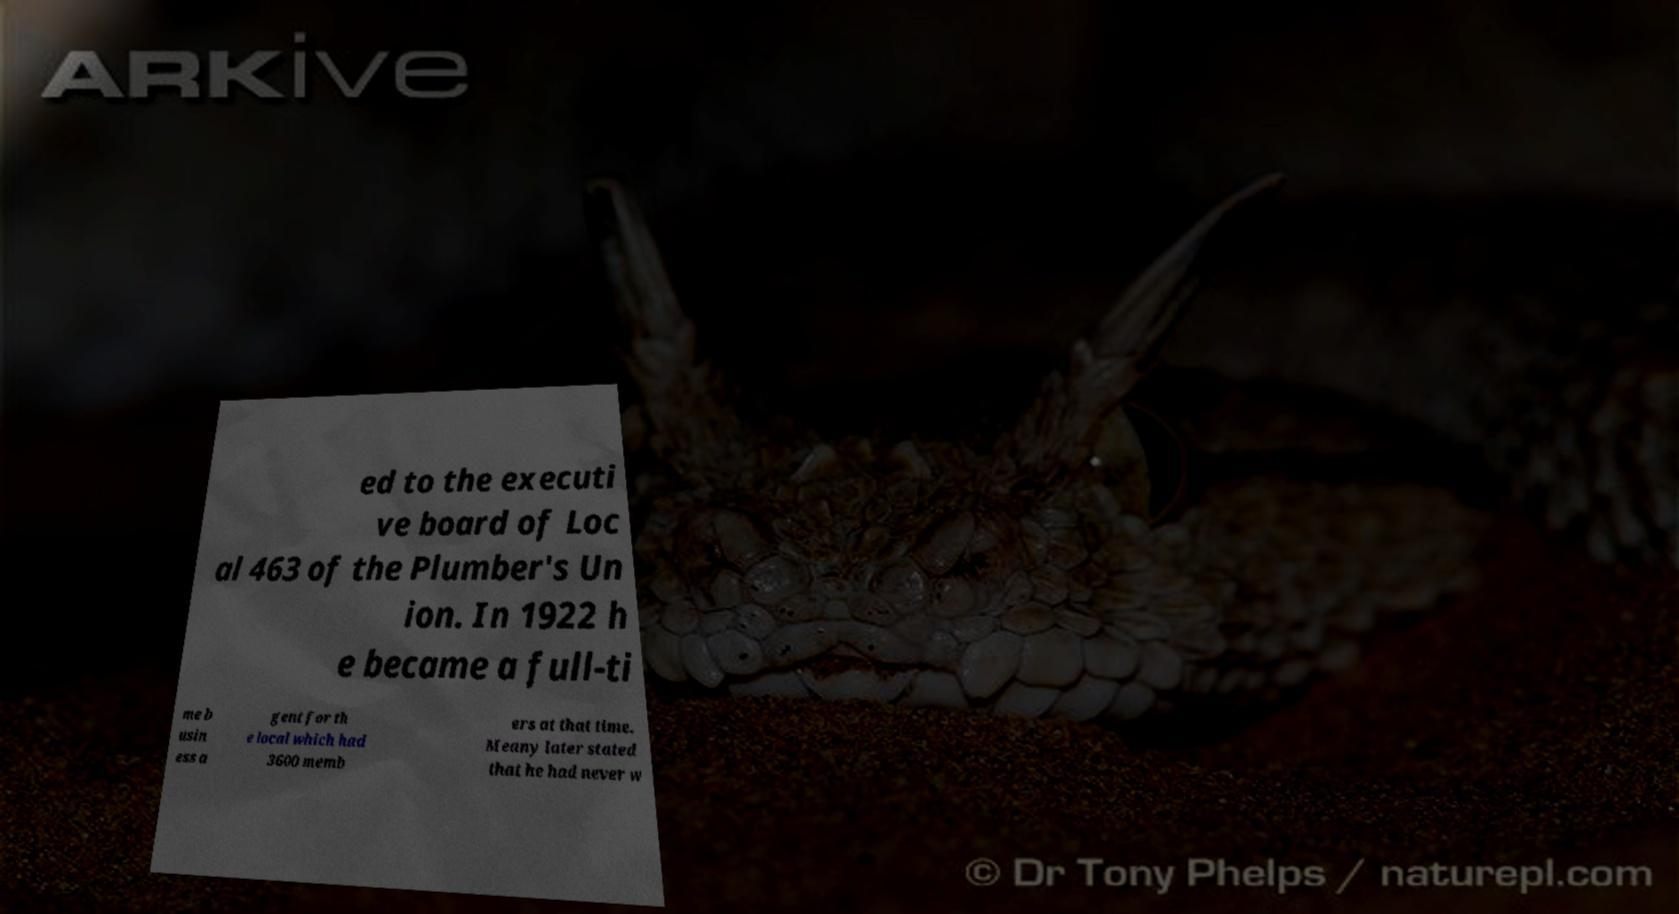Can you read and provide the text displayed in the image?This photo seems to have some interesting text. Can you extract and type it out for me? ed to the executi ve board of Loc al 463 of the Plumber's Un ion. In 1922 h e became a full-ti me b usin ess a gent for th e local which had 3600 memb ers at that time. Meany later stated that he had never w 